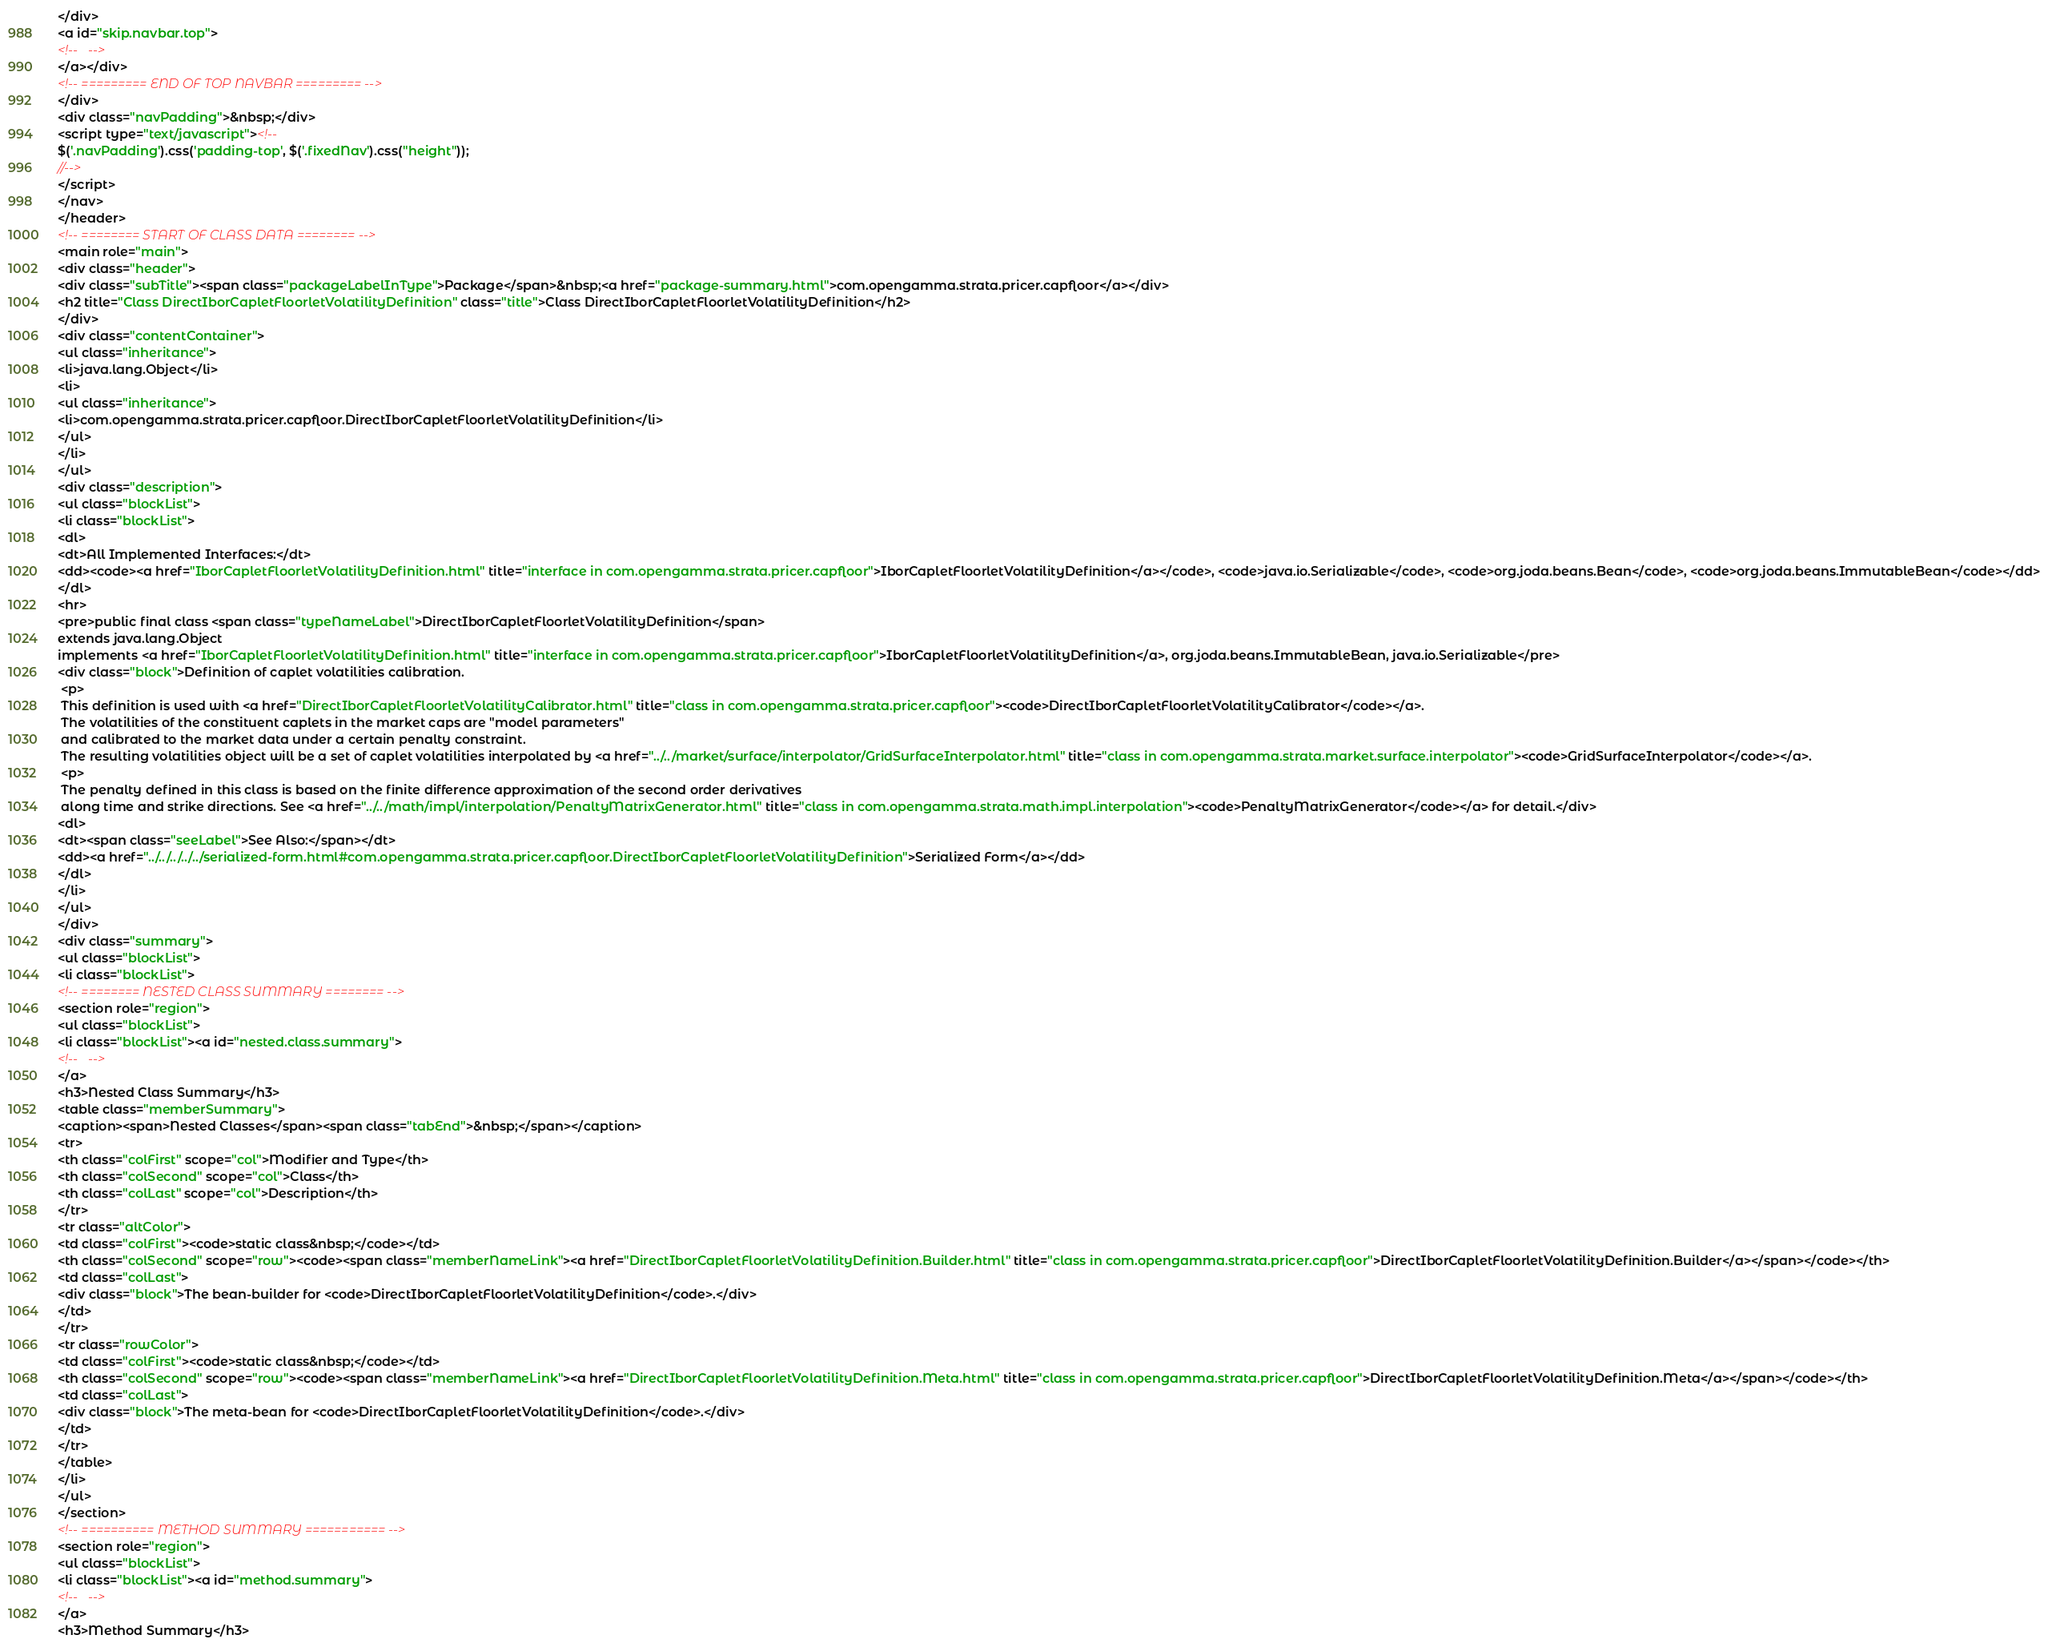Convert code to text. <code><loc_0><loc_0><loc_500><loc_500><_HTML_></div>
<a id="skip.navbar.top">
<!--   -->
</a></div>
<!-- ========= END OF TOP NAVBAR ========= -->
</div>
<div class="navPadding">&nbsp;</div>
<script type="text/javascript"><!--
$('.navPadding').css('padding-top', $('.fixedNav').css("height"));
//-->
</script>
</nav>
</header>
<!-- ======== START OF CLASS DATA ======== -->
<main role="main">
<div class="header">
<div class="subTitle"><span class="packageLabelInType">Package</span>&nbsp;<a href="package-summary.html">com.opengamma.strata.pricer.capfloor</a></div>
<h2 title="Class DirectIborCapletFloorletVolatilityDefinition" class="title">Class DirectIborCapletFloorletVolatilityDefinition</h2>
</div>
<div class="contentContainer">
<ul class="inheritance">
<li>java.lang.Object</li>
<li>
<ul class="inheritance">
<li>com.opengamma.strata.pricer.capfloor.DirectIborCapletFloorletVolatilityDefinition</li>
</ul>
</li>
</ul>
<div class="description">
<ul class="blockList">
<li class="blockList">
<dl>
<dt>All Implemented Interfaces:</dt>
<dd><code><a href="IborCapletFloorletVolatilityDefinition.html" title="interface in com.opengamma.strata.pricer.capfloor">IborCapletFloorletVolatilityDefinition</a></code>, <code>java.io.Serializable</code>, <code>org.joda.beans.Bean</code>, <code>org.joda.beans.ImmutableBean</code></dd>
</dl>
<hr>
<pre>public final class <span class="typeNameLabel">DirectIborCapletFloorletVolatilityDefinition</span>
extends java.lang.Object
implements <a href="IborCapletFloorletVolatilityDefinition.html" title="interface in com.opengamma.strata.pricer.capfloor">IborCapletFloorletVolatilityDefinition</a>, org.joda.beans.ImmutableBean, java.io.Serializable</pre>
<div class="block">Definition of caplet volatilities calibration.
 <p>
 This definition is used with <a href="DirectIborCapletFloorletVolatilityCalibrator.html" title="class in com.opengamma.strata.pricer.capfloor"><code>DirectIborCapletFloorletVolatilityCalibrator</code></a>. 
 The volatilities of the constituent caplets in the market caps are "model parameters" 
 and calibrated to the market data under a certain penalty constraint.
 The resulting volatilities object will be a set of caplet volatilities interpolated by <a href="../../market/surface/interpolator/GridSurfaceInterpolator.html" title="class in com.opengamma.strata.market.surface.interpolator"><code>GridSurfaceInterpolator</code></a>.
 <p>
 The penalty defined in this class is based on the finite difference approximation of the second order derivatives 
 along time and strike directions. See <a href="../../math/impl/interpolation/PenaltyMatrixGenerator.html" title="class in com.opengamma.strata.math.impl.interpolation"><code>PenaltyMatrixGenerator</code></a> for detail.</div>
<dl>
<dt><span class="seeLabel">See Also:</span></dt>
<dd><a href="../../../../../serialized-form.html#com.opengamma.strata.pricer.capfloor.DirectIborCapletFloorletVolatilityDefinition">Serialized Form</a></dd>
</dl>
</li>
</ul>
</div>
<div class="summary">
<ul class="blockList">
<li class="blockList">
<!-- ======== NESTED CLASS SUMMARY ======== -->
<section role="region">
<ul class="blockList">
<li class="blockList"><a id="nested.class.summary">
<!--   -->
</a>
<h3>Nested Class Summary</h3>
<table class="memberSummary">
<caption><span>Nested Classes</span><span class="tabEnd">&nbsp;</span></caption>
<tr>
<th class="colFirst" scope="col">Modifier and Type</th>
<th class="colSecond" scope="col">Class</th>
<th class="colLast" scope="col">Description</th>
</tr>
<tr class="altColor">
<td class="colFirst"><code>static class&nbsp;</code></td>
<th class="colSecond" scope="row"><code><span class="memberNameLink"><a href="DirectIborCapletFloorletVolatilityDefinition.Builder.html" title="class in com.opengamma.strata.pricer.capfloor">DirectIborCapletFloorletVolatilityDefinition.Builder</a></span></code></th>
<td class="colLast">
<div class="block">The bean-builder for <code>DirectIborCapletFloorletVolatilityDefinition</code>.</div>
</td>
</tr>
<tr class="rowColor">
<td class="colFirst"><code>static class&nbsp;</code></td>
<th class="colSecond" scope="row"><code><span class="memberNameLink"><a href="DirectIborCapletFloorletVolatilityDefinition.Meta.html" title="class in com.opengamma.strata.pricer.capfloor">DirectIborCapletFloorletVolatilityDefinition.Meta</a></span></code></th>
<td class="colLast">
<div class="block">The meta-bean for <code>DirectIborCapletFloorletVolatilityDefinition</code>.</div>
</td>
</tr>
</table>
</li>
</ul>
</section>
<!-- ========== METHOD SUMMARY =========== -->
<section role="region">
<ul class="blockList">
<li class="blockList"><a id="method.summary">
<!--   -->
</a>
<h3>Method Summary</h3></code> 